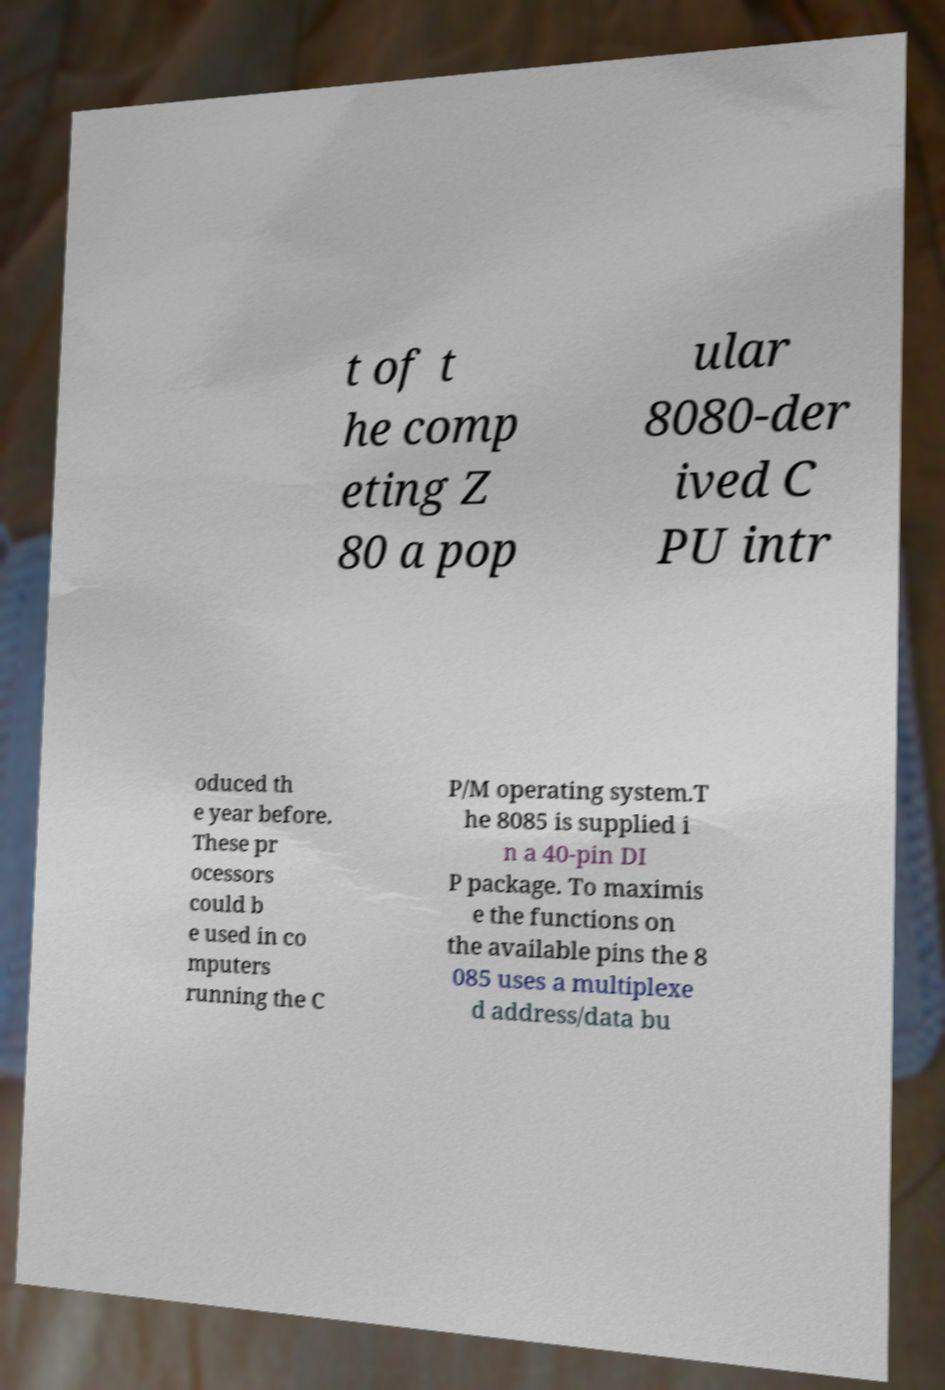I need the written content from this picture converted into text. Can you do that? t of t he comp eting Z 80 a pop ular 8080-der ived C PU intr oduced th e year before. These pr ocessors could b e used in co mputers running the C P/M operating system.T he 8085 is supplied i n a 40-pin DI P package. To maximis e the functions on the available pins the 8 085 uses a multiplexe d address/data bu 